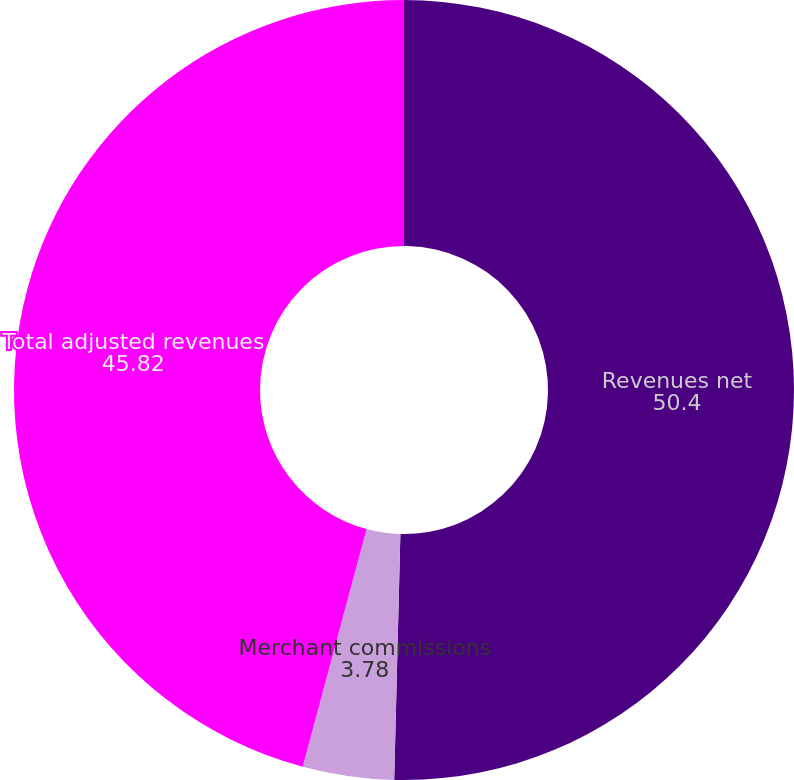<chart> <loc_0><loc_0><loc_500><loc_500><pie_chart><fcel>Revenues net<fcel>Merchant commissions<fcel>Total adjusted revenues<nl><fcel>50.4%<fcel>3.78%<fcel>45.82%<nl></chart> 